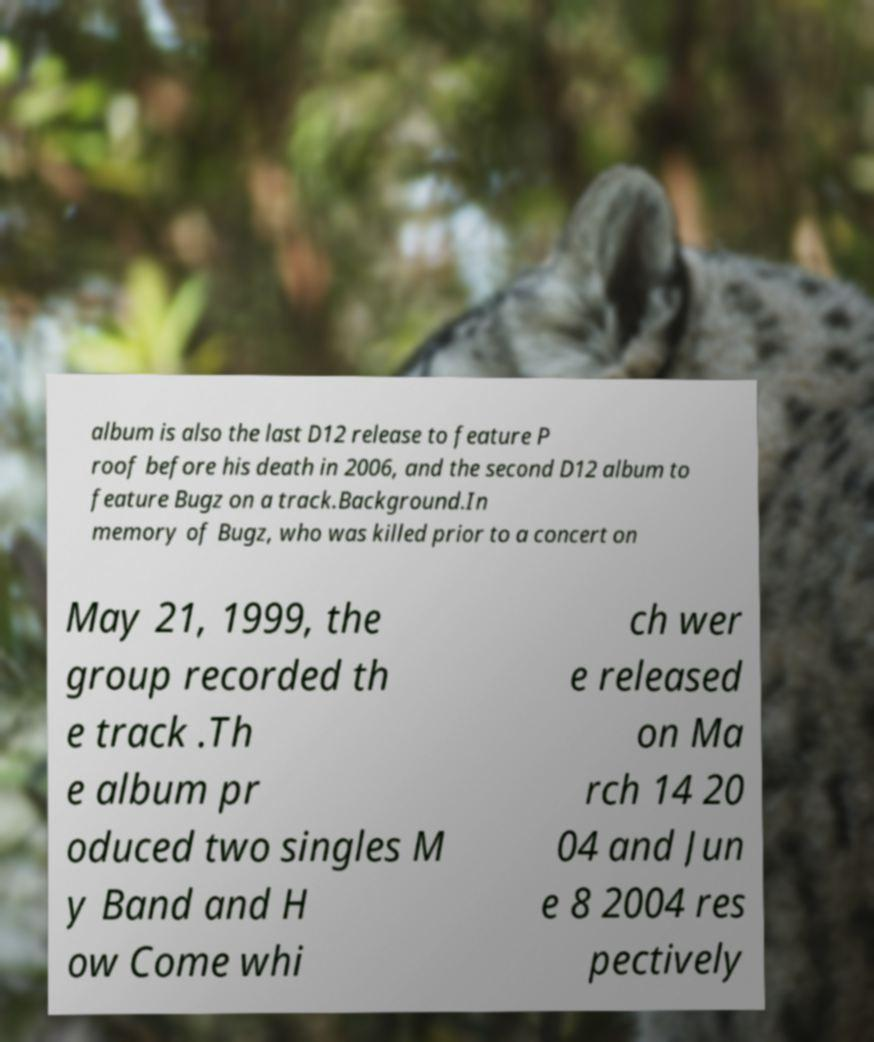Could you extract and type out the text from this image? album is also the last D12 release to feature P roof before his death in 2006, and the second D12 album to feature Bugz on a track.Background.In memory of Bugz, who was killed prior to a concert on May 21, 1999, the group recorded th e track .Th e album pr oduced two singles M y Band and H ow Come whi ch wer e released on Ma rch 14 20 04 and Jun e 8 2004 res pectively 